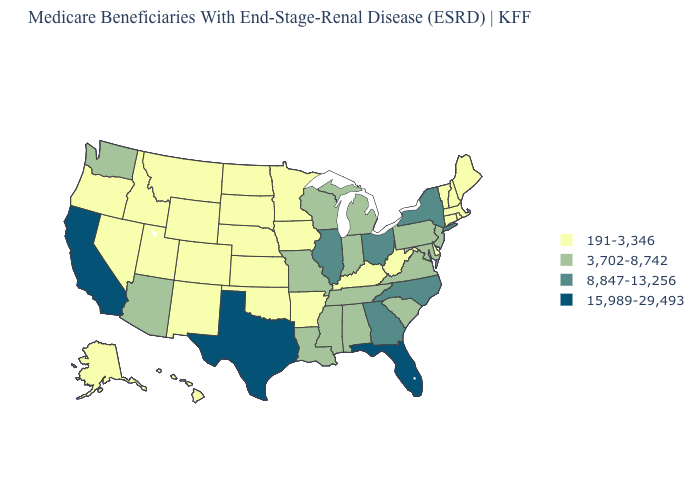Name the states that have a value in the range 8,847-13,256?
Concise answer only. Georgia, Illinois, New York, North Carolina, Ohio. What is the value of Oregon?
Write a very short answer. 191-3,346. What is the value of New Hampshire?
Keep it brief. 191-3,346. Name the states that have a value in the range 15,989-29,493?
Be succinct. California, Florida, Texas. Name the states that have a value in the range 191-3,346?
Short answer required. Alaska, Arkansas, Colorado, Connecticut, Delaware, Hawaii, Idaho, Iowa, Kansas, Kentucky, Maine, Massachusetts, Minnesota, Montana, Nebraska, Nevada, New Hampshire, New Mexico, North Dakota, Oklahoma, Oregon, Rhode Island, South Dakota, Utah, Vermont, West Virginia, Wyoming. Name the states that have a value in the range 3,702-8,742?
Quick response, please. Alabama, Arizona, Indiana, Louisiana, Maryland, Michigan, Mississippi, Missouri, New Jersey, Pennsylvania, South Carolina, Tennessee, Virginia, Washington, Wisconsin. Name the states that have a value in the range 8,847-13,256?
Write a very short answer. Georgia, Illinois, New York, North Carolina, Ohio. Does Montana have a lower value than Delaware?
Write a very short answer. No. Name the states that have a value in the range 191-3,346?
Be succinct. Alaska, Arkansas, Colorado, Connecticut, Delaware, Hawaii, Idaho, Iowa, Kansas, Kentucky, Maine, Massachusetts, Minnesota, Montana, Nebraska, Nevada, New Hampshire, New Mexico, North Dakota, Oklahoma, Oregon, Rhode Island, South Dakota, Utah, Vermont, West Virginia, Wyoming. What is the lowest value in the West?
Answer briefly. 191-3,346. Among the states that border Connecticut , does Massachusetts have the highest value?
Concise answer only. No. What is the value of Nevada?
Concise answer only. 191-3,346. Name the states that have a value in the range 191-3,346?
Quick response, please. Alaska, Arkansas, Colorado, Connecticut, Delaware, Hawaii, Idaho, Iowa, Kansas, Kentucky, Maine, Massachusetts, Minnesota, Montana, Nebraska, Nevada, New Hampshire, New Mexico, North Dakota, Oklahoma, Oregon, Rhode Island, South Dakota, Utah, Vermont, West Virginia, Wyoming. What is the value of Connecticut?
Give a very brief answer. 191-3,346. 